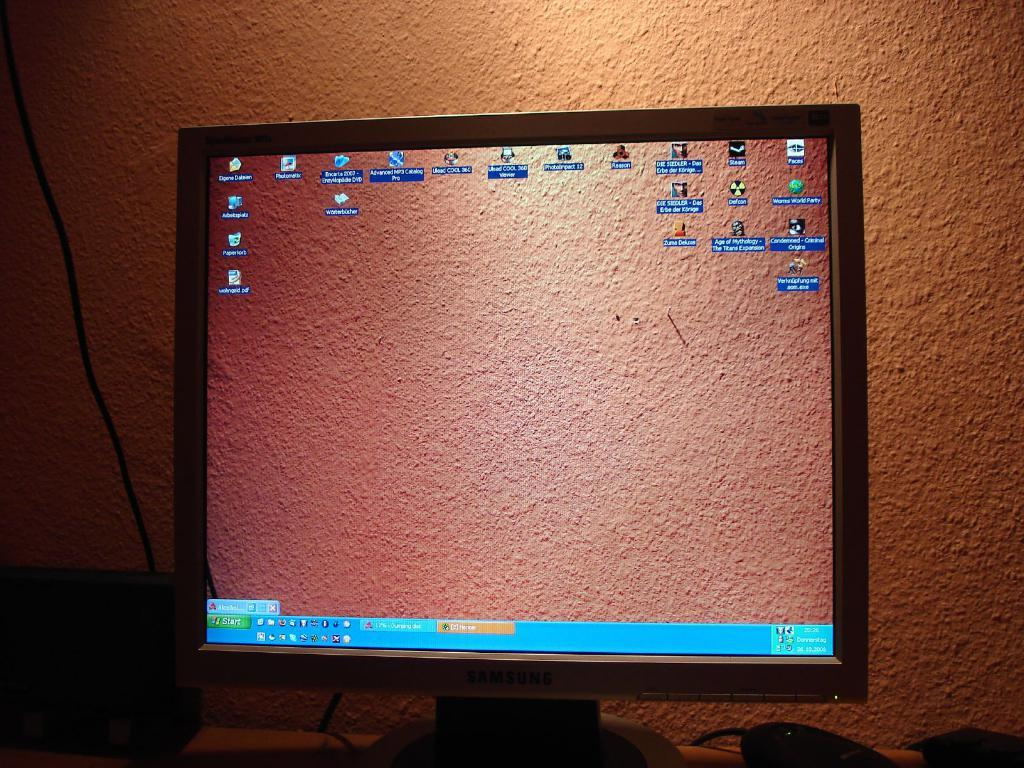<image>
Summarize the visual content of the image. many icons and a start icon in the left 